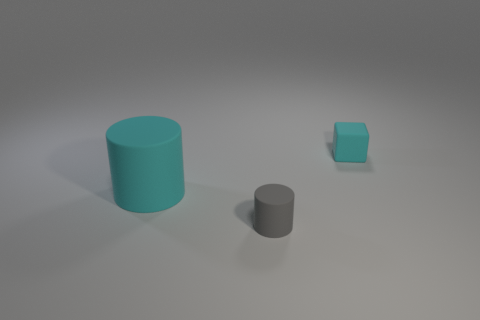Add 1 big things. How many objects exist? 4 Subtract all cylinders. How many objects are left? 1 Add 3 small objects. How many small objects exist? 5 Subtract 0 yellow cylinders. How many objects are left? 3 Subtract all big cyan shiny cylinders. Subtract all gray objects. How many objects are left? 2 Add 2 cyan rubber cylinders. How many cyan rubber cylinders are left? 3 